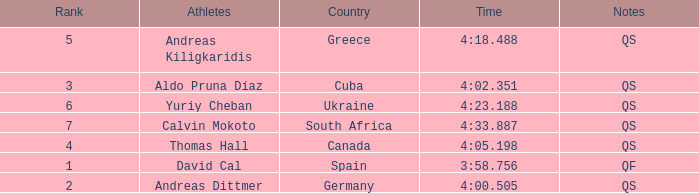What are the notes for the athlete from Spain? QF. 